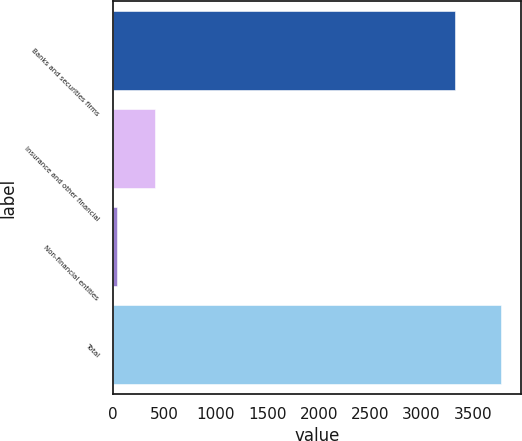Convert chart. <chart><loc_0><loc_0><loc_500><loc_500><bar_chart><fcel>Banks and securities firms<fcel>Insurance and other financial<fcel>Non-financial entities<fcel>Total<nl><fcel>3329<fcel>412.4<fcel>39<fcel>3773<nl></chart> 